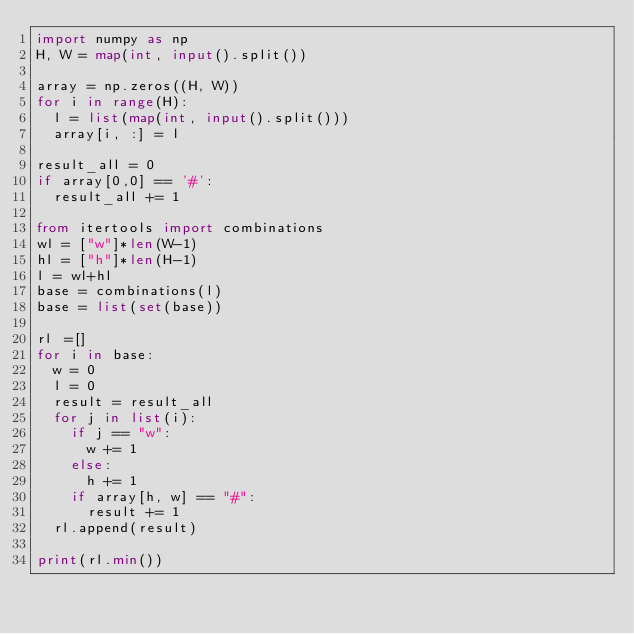Convert code to text. <code><loc_0><loc_0><loc_500><loc_500><_Python_>import numpy as np
H, W = map(int, input().split())

array = np.zeros((H, W))
for i in range(H):
  l = list(map(int, input().split()))
  array[i, :] = l

result_all = 0
if array[0,0] == '#':
  result_all += 1

from itertools import combinations
wl = ["w"]*len(W-1)
hl = ["h"]*len(H-1)
l = wl+hl
base = combinations(l)
base = list(set(base))

rl =[]
for i in base:
  w = 0
  l = 0
  result = result_all
  for j in list(i):
    if j == "w":
      w += 1
    else:
      h += 1
    if array[h, w] == "#":
      result += 1
  rl.append(result)
  
print(rl.min())</code> 